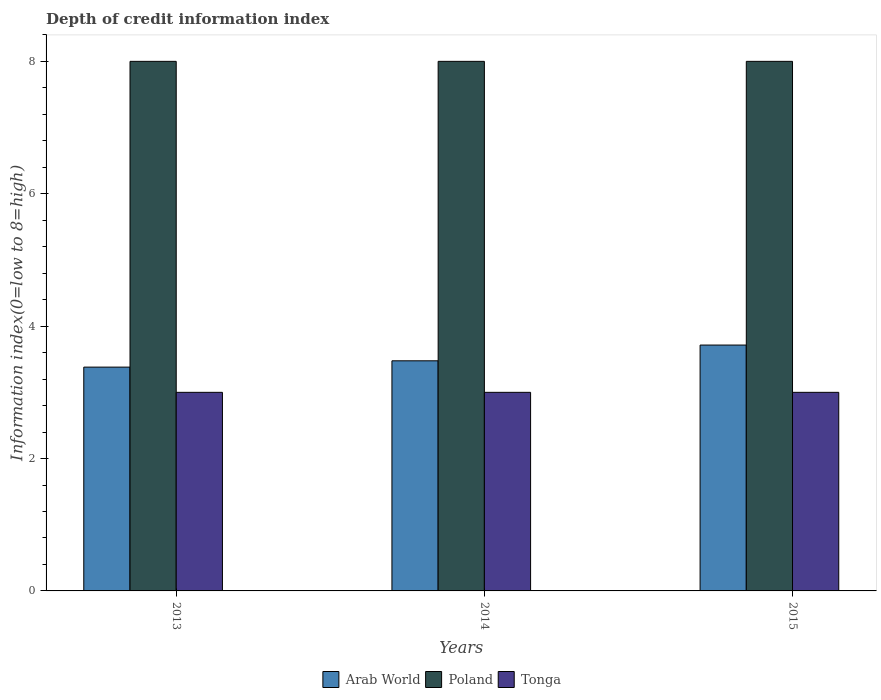How many groups of bars are there?
Make the answer very short. 3. Are the number of bars per tick equal to the number of legend labels?
Ensure brevity in your answer.  Yes. How many bars are there on the 1st tick from the left?
Your answer should be compact. 3. What is the label of the 1st group of bars from the left?
Offer a terse response. 2013. What is the information index in Arab World in 2015?
Your answer should be very brief. 3.71. Across all years, what is the maximum information index in Poland?
Keep it short and to the point. 8. Across all years, what is the minimum information index in Tonga?
Ensure brevity in your answer.  3. In which year was the information index in Tonga maximum?
Offer a very short reply. 2013. In which year was the information index in Tonga minimum?
Your answer should be compact. 2013. What is the total information index in Tonga in the graph?
Ensure brevity in your answer.  9. What is the difference between the information index in Tonga in 2013 and that in 2014?
Ensure brevity in your answer.  0. What is the difference between the information index in Arab World in 2015 and the information index in Tonga in 2013?
Your answer should be very brief. 0.71. What is the average information index in Tonga per year?
Provide a short and direct response. 3. In the year 2013, what is the difference between the information index in Arab World and information index in Tonga?
Make the answer very short. 0.38. What is the ratio of the information index in Poland in 2013 to that in 2014?
Ensure brevity in your answer.  1. Is the information index in Poland in 2013 less than that in 2015?
Provide a short and direct response. No. Is the difference between the information index in Arab World in 2014 and 2015 greater than the difference between the information index in Tonga in 2014 and 2015?
Offer a very short reply. No. What is the difference between the highest and the second highest information index in Poland?
Make the answer very short. 0. In how many years, is the information index in Tonga greater than the average information index in Tonga taken over all years?
Your response must be concise. 0. What does the 3rd bar from the right in 2013 represents?
Your answer should be very brief. Arab World. Is it the case that in every year, the sum of the information index in Poland and information index in Arab World is greater than the information index in Tonga?
Ensure brevity in your answer.  Yes. Are all the bars in the graph horizontal?
Your answer should be very brief. No. Are the values on the major ticks of Y-axis written in scientific E-notation?
Give a very brief answer. No. Does the graph contain grids?
Ensure brevity in your answer.  No. How are the legend labels stacked?
Give a very brief answer. Horizontal. What is the title of the graph?
Your answer should be compact. Depth of credit information index. Does "Belgium" appear as one of the legend labels in the graph?
Ensure brevity in your answer.  No. What is the label or title of the X-axis?
Provide a short and direct response. Years. What is the label or title of the Y-axis?
Offer a very short reply. Information index(0=low to 8=high). What is the Information index(0=low to 8=high) of Arab World in 2013?
Provide a short and direct response. 3.38. What is the Information index(0=low to 8=high) in Tonga in 2013?
Your response must be concise. 3. What is the Information index(0=low to 8=high) of Arab World in 2014?
Give a very brief answer. 3.48. What is the Information index(0=low to 8=high) in Arab World in 2015?
Give a very brief answer. 3.71. What is the Information index(0=low to 8=high) in Poland in 2015?
Keep it short and to the point. 8. Across all years, what is the maximum Information index(0=low to 8=high) in Arab World?
Offer a very short reply. 3.71. Across all years, what is the maximum Information index(0=low to 8=high) in Poland?
Your answer should be compact. 8. Across all years, what is the minimum Information index(0=low to 8=high) in Arab World?
Provide a short and direct response. 3.38. Across all years, what is the minimum Information index(0=low to 8=high) of Poland?
Provide a short and direct response. 8. What is the total Information index(0=low to 8=high) in Arab World in the graph?
Provide a succinct answer. 10.57. What is the total Information index(0=low to 8=high) in Poland in the graph?
Ensure brevity in your answer.  24. What is the total Information index(0=low to 8=high) of Tonga in the graph?
Offer a very short reply. 9. What is the difference between the Information index(0=low to 8=high) of Arab World in 2013 and that in 2014?
Your answer should be very brief. -0.1. What is the difference between the Information index(0=low to 8=high) of Tonga in 2013 and that in 2014?
Make the answer very short. 0. What is the difference between the Information index(0=low to 8=high) in Tonga in 2013 and that in 2015?
Provide a short and direct response. 0. What is the difference between the Information index(0=low to 8=high) in Arab World in 2014 and that in 2015?
Give a very brief answer. -0.24. What is the difference between the Information index(0=low to 8=high) in Poland in 2014 and that in 2015?
Offer a terse response. 0. What is the difference between the Information index(0=low to 8=high) of Arab World in 2013 and the Information index(0=low to 8=high) of Poland in 2014?
Your answer should be very brief. -4.62. What is the difference between the Information index(0=low to 8=high) in Arab World in 2013 and the Information index(0=low to 8=high) in Tonga in 2014?
Provide a succinct answer. 0.38. What is the difference between the Information index(0=low to 8=high) in Poland in 2013 and the Information index(0=low to 8=high) in Tonga in 2014?
Keep it short and to the point. 5. What is the difference between the Information index(0=low to 8=high) in Arab World in 2013 and the Information index(0=low to 8=high) in Poland in 2015?
Give a very brief answer. -4.62. What is the difference between the Information index(0=low to 8=high) of Arab World in 2013 and the Information index(0=low to 8=high) of Tonga in 2015?
Give a very brief answer. 0.38. What is the difference between the Information index(0=low to 8=high) of Poland in 2013 and the Information index(0=low to 8=high) of Tonga in 2015?
Provide a short and direct response. 5. What is the difference between the Information index(0=low to 8=high) of Arab World in 2014 and the Information index(0=low to 8=high) of Poland in 2015?
Make the answer very short. -4.52. What is the difference between the Information index(0=low to 8=high) in Arab World in 2014 and the Information index(0=low to 8=high) in Tonga in 2015?
Offer a terse response. 0.48. What is the difference between the Information index(0=low to 8=high) in Poland in 2014 and the Information index(0=low to 8=high) in Tonga in 2015?
Offer a very short reply. 5. What is the average Information index(0=low to 8=high) in Arab World per year?
Provide a short and direct response. 3.52. What is the average Information index(0=low to 8=high) in Poland per year?
Your response must be concise. 8. What is the average Information index(0=low to 8=high) of Tonga per year?
Keep it short and to the point. 3. In the year 2013, what is the difference between the Information index(0=low to 8=high) of Arab World and Information index(0=low to 8=high) of Poland?
Offer a very short reply. -4.62. In the year 2013, what is the difference between the Information index(0=low to 8=high) of Arab World and Information index(0=low to 8=high) of Tonga?
Offer a terse response. 0.38. In the year 2013, what is the difference between the Information index(0=low to 8=high) of Poland and Information index(0=low to 8=high) of Tonga?
Your answer should be very brief. 5. In the year 2014, what is the difference between the Information index(0=low to 8=high) of Arab World and Information index(0=low to 8=high) of Poland?
Provide a succinct answer. -4.52. In the year 2014, what is the difference between the Information index(0=low to 8=high) in Arab World and Information index(0=low to 8=high) in Tonga?
Provide a short and direct response. 0.48. In the year 2015, what is the difference between the Information index(0=low to 8=high) of Arab World and Information index(0=low to 8=high) of Poland?
Your response must be concise. -4.29. In the year 2015, what is the difference between the Information index(0=low to 8=high) of Arab World and Information index(0=low to 8=high) of Tonga?
Offer a very short reply. 0.71. In the year 2015, what is the difference between the Information index(0=low to 8=high) in Poland and Information index(0=low to 8=high) in Tonga?
Keep it short and to the point. 5. What is the ratio of the Information index(0=low to 8=high) in Arab World in 2013 to that in 2014?
Your answer should be compact. 0.97. What is the ratio of the Information index(0=low to 8=high) in Tonga in 2013 to that in 2014?
Make the answer very short. 1. What is the ratio of the Information index(0=low to 8=high) in Arab World in 2013 to that in 2015?
Offer a very short reply. 0.91. What is the ratio of the Information index(0=low to 8=high) in Poland in 2013 to that in 2015?
Offer a terse response. 1. What is the ratio of the Information index(0=low to 8=high) in Arab World in 2014 to that in 2015?
Provide a short and direct response. 0.94. What is the ratio of the Information index(0=low to 8=high) of Poland in 2014 to that in 2015?
Offer a very short reply. 1. What is the ratio of the Information index(0=low to 8=high) of Tonga in 2014 to that in 2015?
Your response must be concise. 1. What is the difference between the highest and the second highest Information index(0=low to 8=high) of Arab World?
Offer a terse response. 0.24. What is the difference between the highest and the second highest Information index(0=low to 8=high) in Poland?
Your answer should be compact. 0. What is the difference between the highest and the lowest Information index(0=low to 8=high) of Poland?
Your answer should be very brief. 0. What is the difference between the highest and the lowest Information index(0=low to 8=high) of Tonga?
Offer a terse response. 0. 